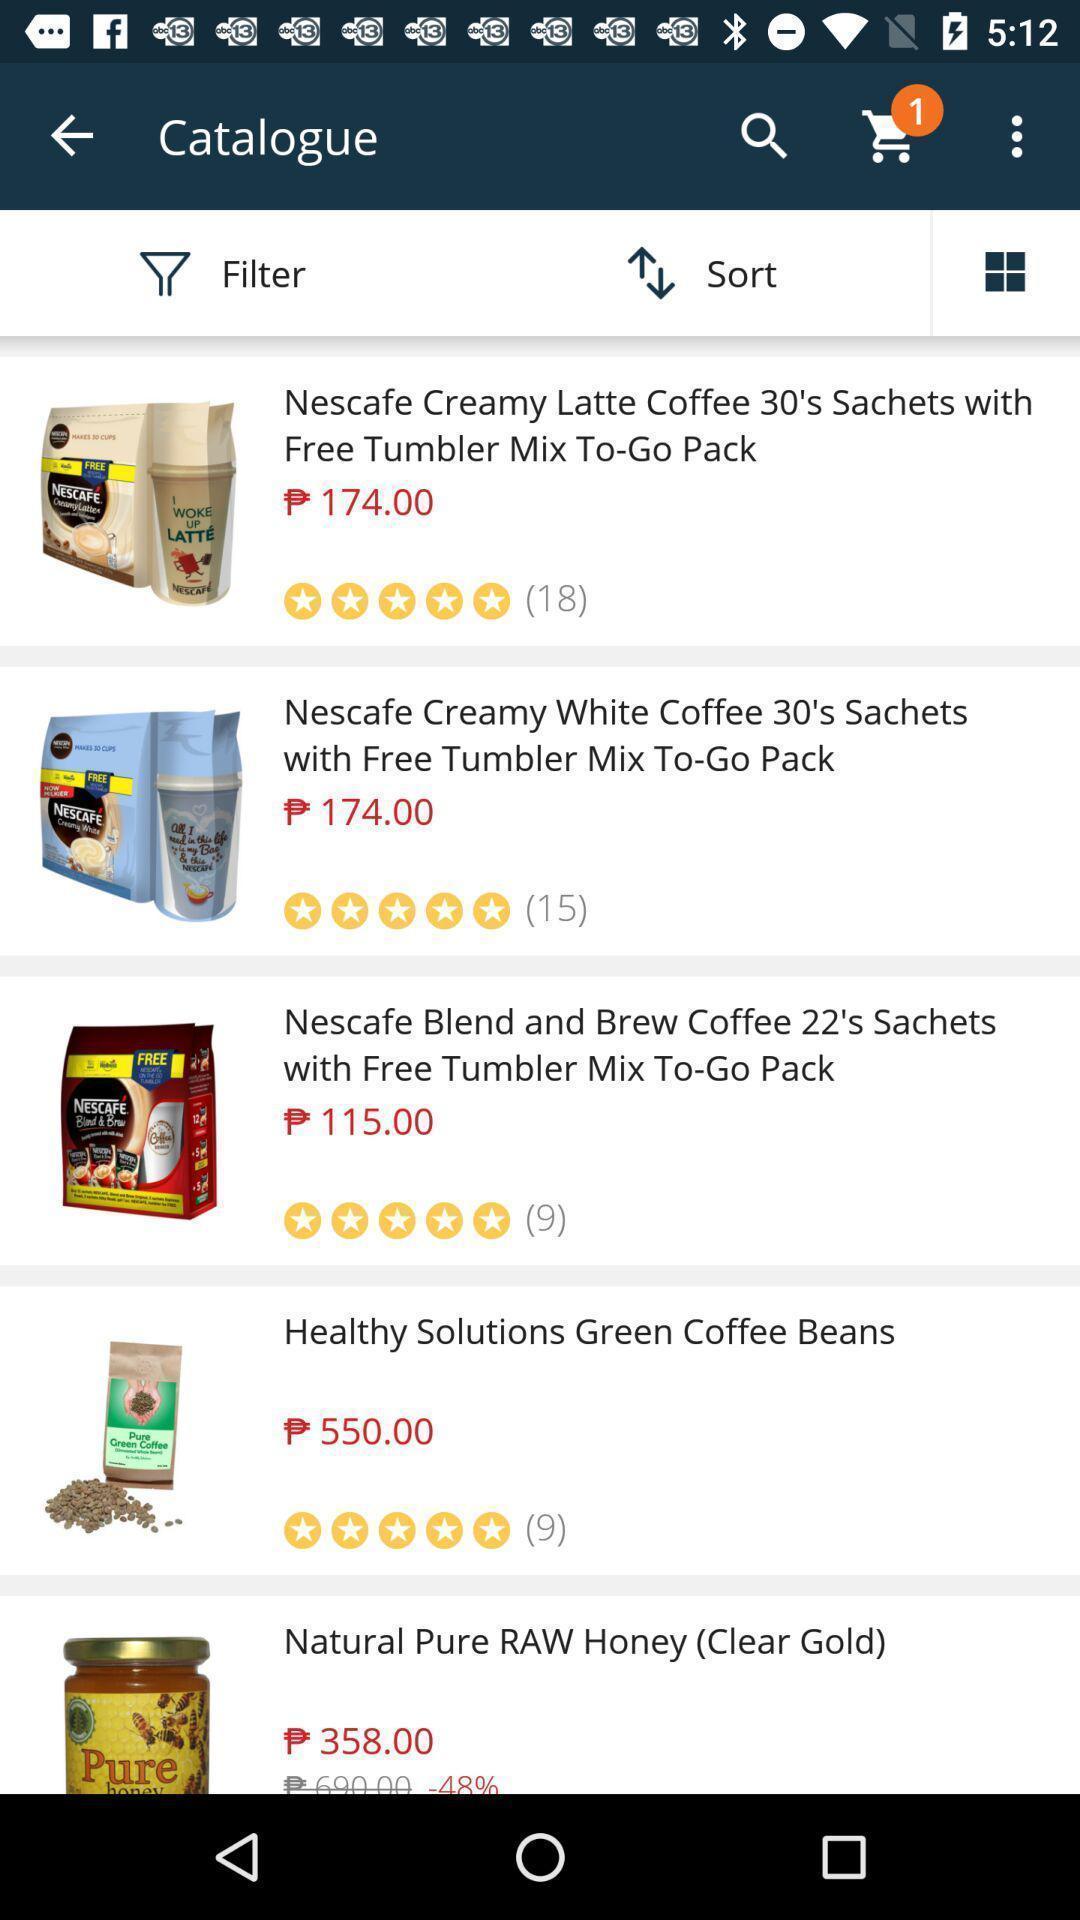Explain what's happening in this screen capture. Screen showing catalogue. 